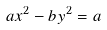Convert formula to latex. <formula><loc_0><loc_0><loc_500><loc_500>a x ^ { 2 } - b y ^ { 2 } = a</formula> 